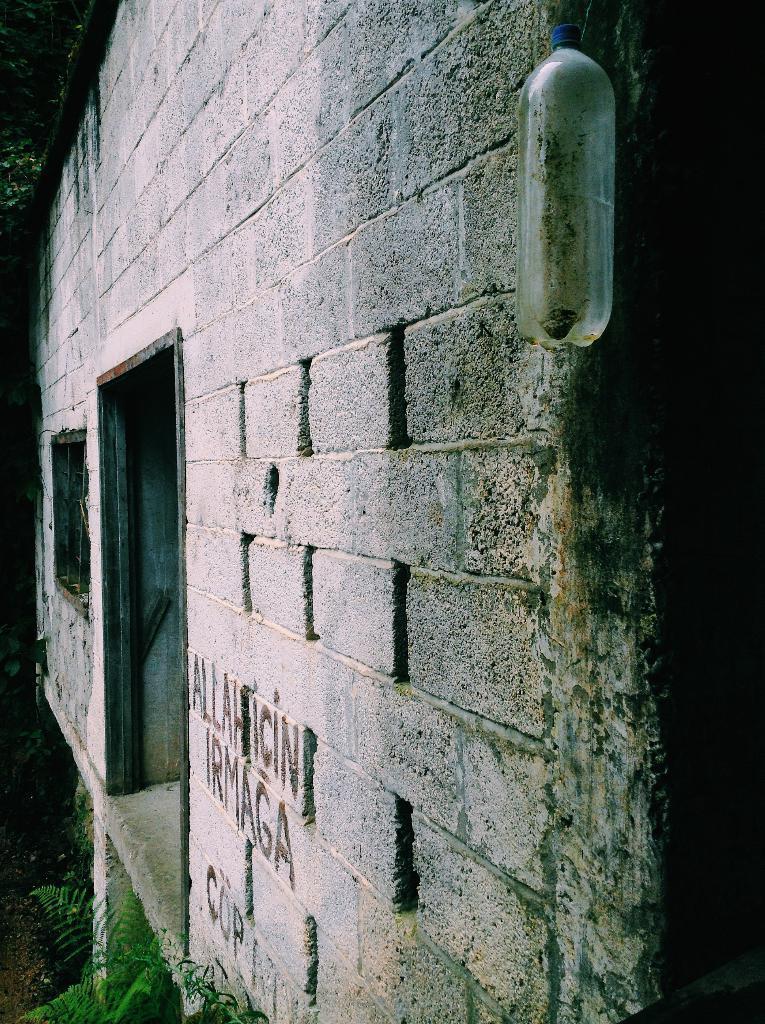Can you describe this image briefly? This image is taken outdoors. At the bottom of the image there is a plant. In the middle of the image there is a wall with a window and there is a bottle. 